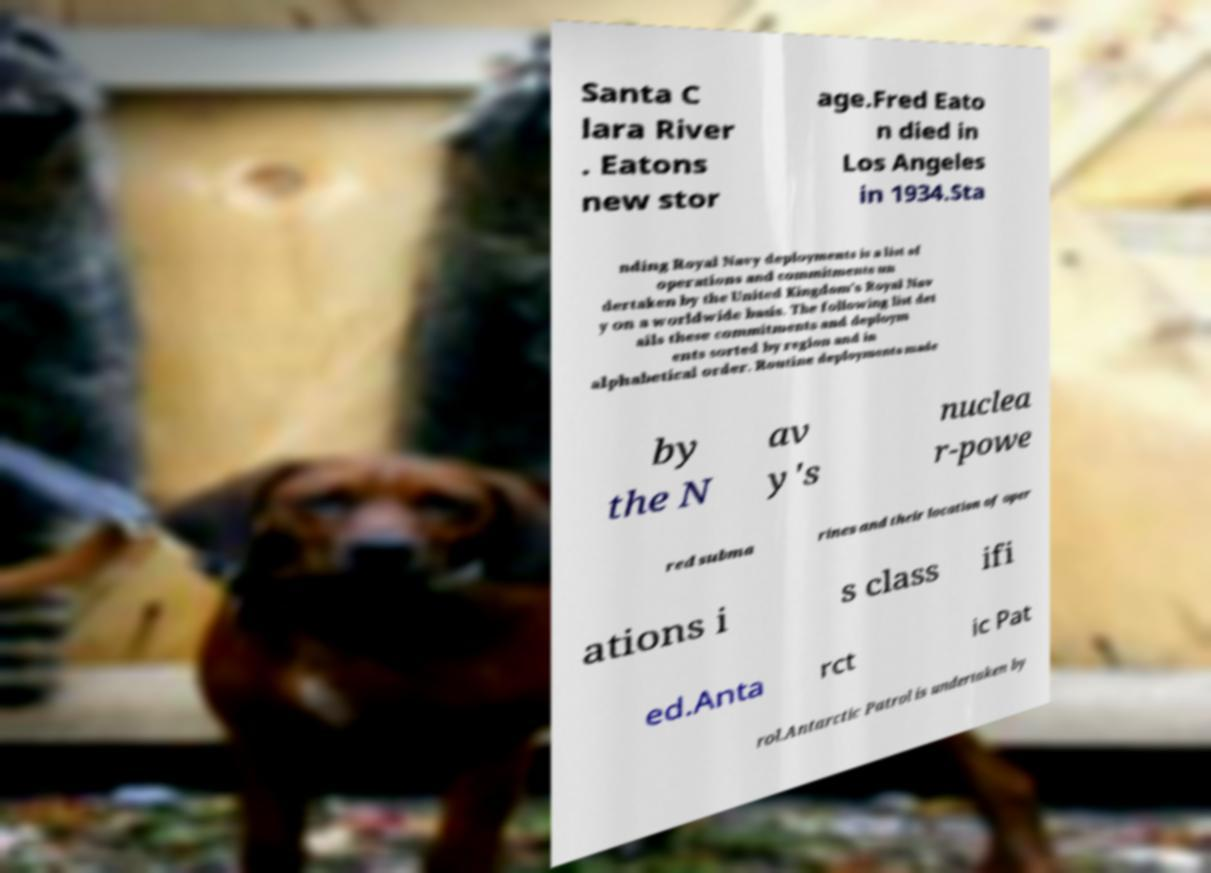What messages or text are displayed in this image? I need them in a readable, typed format. Santa C lara River . Eatons new stor age.Fred Eato n died in Los Angeles in 1934.Sta nding Royal Navy deployments is a list of operations and commitments un dertaken by the United Kingdom's Royal Nav y on a worldwide basis. The following list det ails these commitments and deploym ents sorted by region and in alphabetical order. Routine deployments made by the N av y's nuclea r-powe red subma rines and their location of oper ations i s class ifi ed.Anta rct ic Pat rol.Antarctic Patrol is undertaken by 